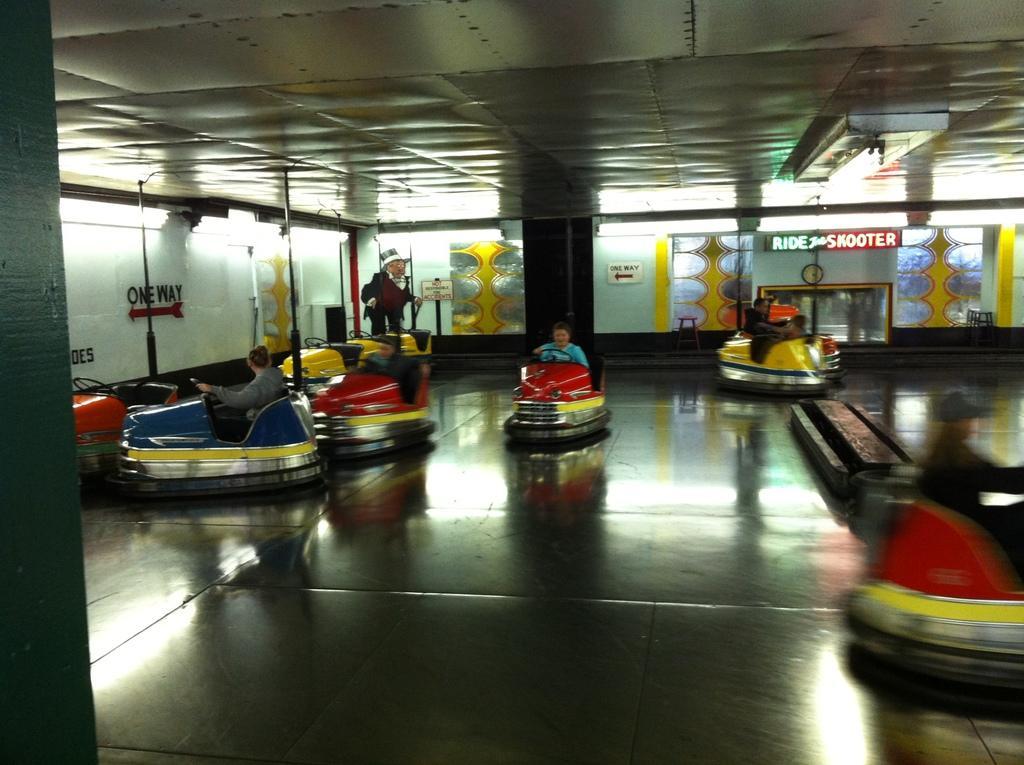How would you summarize this image in a sentence or two? In this image I can see few people riding the cars. I can see these cars are in red, yellow and blue color. In the background I can see the boards and the glasses. 